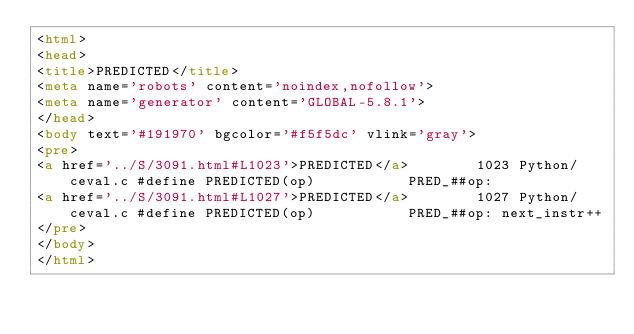Convert code to text. <code><loc_0><loc_0><loc_500><loc_500><_HTML_><html>
<head>
<title>PREDICTED</title>
<meta name='robots' content='noindex,nofollow'>
<meta name='generator' content='GLOBAL-5.8.1'>
</head>
<body text='#191970' bgcolor='#f5f5dc' vlink='gray'>
<pre>
<a href='../S/3091.html#L1023'>PREDICTED</a>        1023 Python/ceval.c #define PREDICTED(op)           PRED_##op:
<a href='../S/3091.html#L1027'>PREDICTED</a>        1027 Python/ceval.c #define PREDICTED(op)           PRED_##op: next_instr++
</pre>
</body>
</html>
</code> 